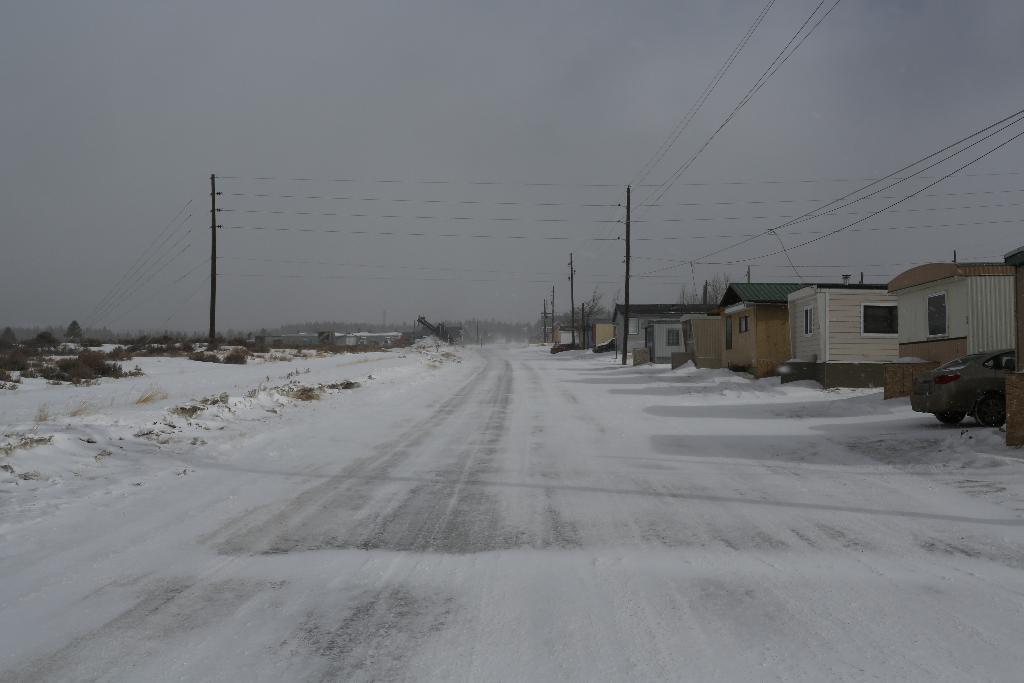Please provide a concise description of this image. In this picture we can see the road with snow on it, poles, wires, houses with windows, car, trees and in the background we can see the sky. 